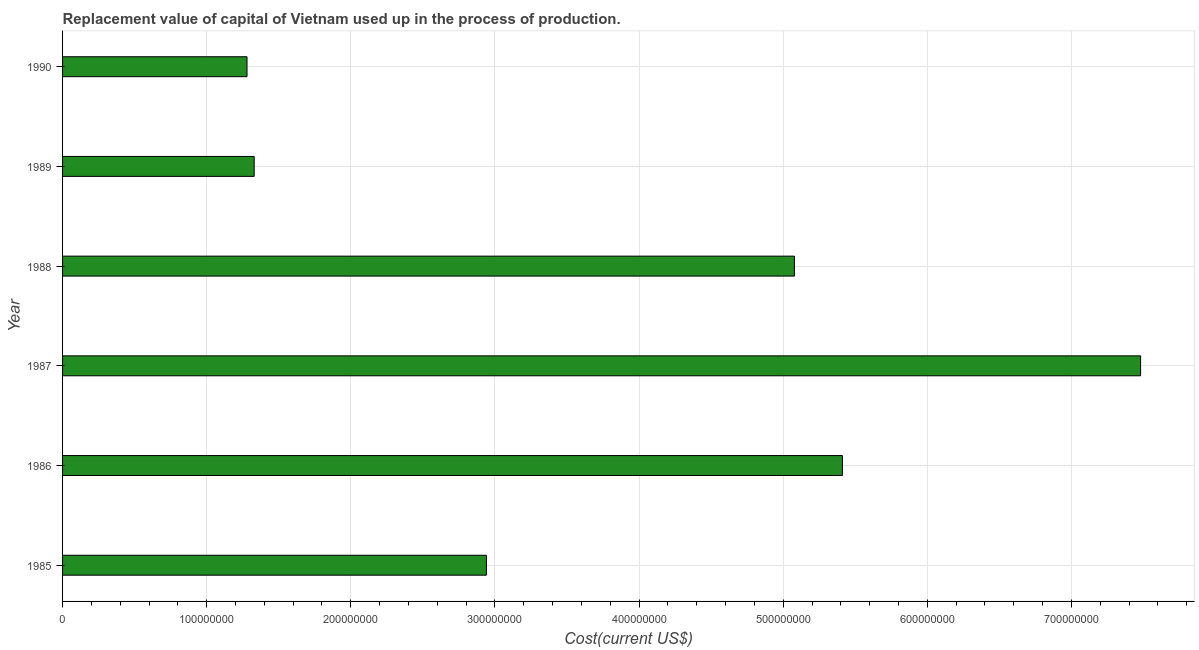Does the graph contain any zero values?
Your answer should be very brief. No. What is the title of the graph?
Offer a terse response. Replacement value of capital of Vietnam used up in the process of production. What is the label or title of the X-axis?
Provide a succinct answer. Cost(current US$). What is the label or title of the Y-axis?
Provide a succinct answer. Year. What is the consumption of fixed capital in 1990?
Keep it short and to the point. 1.28e+08. Across all years, what is the maximum consumption of fixed capital?
Keep it short and to the point. 7.48e+08. Across all years, what is the minimum consumption of fixed capital?
Make the answer very short. 1.28e+08. In which year was the consumption of fixed capital minimum?
Make the answer very short. 1990. What is the sum of the consumption of fixed capital?
Your answer should be very brief. 2.35e+09. What is the difference between the consumption of fixed capital in 1985 and 1990?
Offer a very short reply. 1.66e+08. What is the average consumption of fixed capital per year?
Provide a short and direct response. 3.92e+08. What is the median consumption of fixed capital?
Offer a very short reply. 4.01e+08. What is the ratio of the consumption of fixed capital in 1986 to that in 1988?
Ensure brevity in your answer.  1.07. What is the difference between the highest and the second highest consumption of fixed capital?
Keep it short and to the point. 2.07e+08. Is the sum of the consumption of fixed capital in 1987 and 1990 greater than the maximum consumption of fixed capital across all years?
Ensure brevity in your answer.  Yes. What is the difference between the highest and the lowest consumption of fixed capital?
Offer a terse response. 6.20e+08. In how many years, is the consumption of fixed capital greater than the average consumption of fixed capital taken over all years?
Make the answer very short. 3. How many bars are there?
Offer a terse response. 6. Are all the bars in the graph horizontal?
Provide a short and direct response. Yes. What is the Cost(current US$) in 1985?
Provide a short and direct response. 2.94e+08. What is the Cost(current US$) of 1986?
Offer a very short reply. 5.41e+08. What is the Cost(current US$) of 1987?
Provide a short and direct response. 7.48e+08. What is the Cost(current US$) of 1988?
Give a very brief answer. 5.08e+08. What is the Cost(current US$) of 1989?
Provide a short and direct response. 1.33e+08. What is the Cost(current US$) in 1990?
Ensure brevity in your answer.  1.28e+08. What is the difference between the Cost(current US$) in 1985 and 1986?
Keep it short and to the point. -2.47e+08. What is the difference between the Cost(current US$) in 1985 and 1987?
Make the answer very short. -4.54e+08. What is the difference between the Cost(current US$) in 1985 and 1988?
Keep it short and to the point. -2.14e+08. What is the difference between the Cost(current US$) in 1985 and 1989?
Offer a terse response. 1.61e+08. What is the difference between the Cost(current US$) in 1985 and 1990?
Give a very brief answer. 1.66e+08. What is the difference between the Cost(current US$) in 1986 and 1987?
Make the answer very short. -2.07e+08. What is the difference between the Cost(current US$) in 1986 and 1988?
Provide a short and direct response. 3.33e+07. What is the difference between the Cost(current US$) in 1986 and 1989?
Give a very brief answer. 4.08e+08. What is the difference between the Cost(current US$) in 1986 and 1990?
Your answer should be compact. 4.13e+08. What is the difference between the Cost(current US$) in 1987 and 1988?
Provide a short and direct response. 2.40e+08. What is the difference between the Cost(current US$) in 1987 and 1989?
Make the answer very short. 6.15e+08. What is the difference between the Cost(current US$) in 1987 and 1990?
Offer a very short reply. 6.20e+08. What is the difference between the Cost(current US$) in 1988 and 1989?
Offer a very short reply. 3.75e+08. What is the difference between the Cost(current US$) in 1988 and 1990?
Keep it short and to the point. 3.80e+08. What is the difference between the Cost(current US$) in 1989 and 1990?
Your response must be concise. 4.98e+06. What is the ratio of the Cost(current US$) in 1985 to that in 1986?
Make the answer very short. 0.54. What is the ratio of the Cost(current US$) in 1985 to that in 1987?
Ensure brevity in your answer.  0.39. What is the ratio of the Cost(current US$) in 1985 to that in 1988?
Keep it short and to the point. 0.58. What is the ratio of the Cost(current US$) in 1985 to that in 1989?
Offer a terse response. 2.21. What is the ratio of the Cost(current US$) in 1985 to that in 1990?
Keep it short and to the point. 2.3. What is the ratio of the Cost(current US$) in 1986 to that in 1987?
Your answer should be very brief. 0.72. What is the ratio of the Cost(current US$) in 1986 to that in 1988?
Give a very brief answer. 1.07. What is the ratio of the Cost(current US$) in 1986 to that in 1989?
Ensure brevity in your answer.  4.07. What is the ratio of the Cost(current US$) in 1986 to that in 1990?
Offer a very short reply. 4.23. What is the ratio of the Cost(current US$) in 1987 to that in 1988?
Make the answer very short. 1.47. What is the ratio of the Cost(current US$) in 1987 to that in 1989?
Keep it short and to the point. 5.63. What is the ratio of the Cost(current US$) in 1987 to that in 1990?
Ensure brevity in your answer.  5.84. What is the ratio of the Cost(current US$) in 1988 to that in 1989?
Provide a succinct answer. 3.82. What is the ratio of the Cost(current US$) in 1988 to that in 1990?
Your response must be concise. 3.97. What is the ratio of the Cost(current US$) in 1989 to that in 1990?
Your response must be concise. 1.04. 